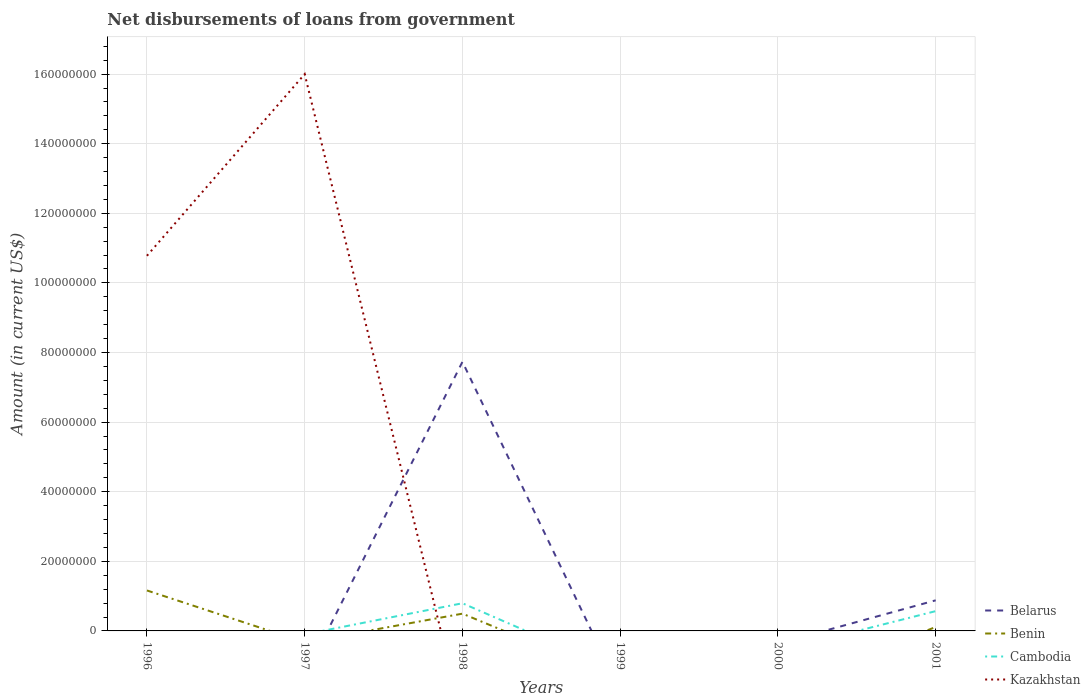Does the line corresponding to Belarus intersect with the line corresponding to Cambodia?
Keep it short and to the point. Yes. Across all years, what is the maximum amount of loan disbursed from government in Kazakhstan?
Your response must be concise. 0. What is the difference between the highest and the second highest amount of loan disbursed from government in Cambodia?
Keep it short and to the point. 7.95e+06. What is the difference between the highest and the lowest amount of loan disbursed from government in Benin?
Provide a short and direct response. 2. Is the amount of loan disbursed from government in Belarus strictly greater than the amount of loan disbursed from government in Kazakhstan over the years?
Your answer should be compact. No. Does the graph contain any zero values?
Provide a succinct answer. Yes. Does the graph contain grids?
Offer a very short reply. Yes. Where does the legend appear in the graph?
Offer a very short reply. Bottom right. How many legend labels are there?
Make the answer very short. 4. What is the title of the graph?
Your answer should be very brief. Net disbursements of loans from government. What is the Amount (in current US$) in Benin in 1996?
Your response must be concise. 1.16e+07. What is the Amount (in current US$) in Kazakhstan in 1996?
Ensure brevity in your answer.  1.08e+08. What is the Amount (in current US$) in Benin in 1997?
Ensure brevity in your answer.  0. What is the Amount (in current US$) of Cambodia in 1997?
Your answer should be compact. 0. What is the Amount (in current US$) in Kazakhstan in 1997?
Your answer should be very brief. 1.60e+08. What is the Amount (in current US$) in Belarus in 1998?
Make the answer very short. 7.73e+07. What is the Amount (in current US$) in Benin in 1998?
Offer a very short reply. 4.96e+06. What is the Amount (in current US$) of Cambodia in 1998?
Your answer should be very brief. 7.95e+06. What is the Amount (in current US$) in Benin in 1999?
Ensure brevity in your answer.  0. What is the Amount (in current US$) in Kazakhstan in 1999?
Your answer should be very brief. 0. What is the Amount (in current US$) of Benin in 2000?
Give a very brief answer. 0. What is the Amount (in current US$) in Cambodia in 2000?
Provide a short and direct response. 0. What is the Amount (in current US$) of Kazakhstan in 2000?
Ensure brevity in your answer.  0. What is the Amount (in current US$) of Belarus in 2001?
Offer a very short reply. 8.79e+06. What is the Amount (in current US$) in Benin in 2001?
Your answer should be very brief. 1.12e+06. What is the Amount (in current US$) of Cambodia in 2001?
Offer a terse response. 5.69e+06. Across all years, what is the maximum Amount (in current US$) of Belarus?
Give a very brief answer. 7.73e+07. Across all years, what is the maximum Amount (in current US$) in Benin?
Give a very brief answer. 1.16e+07. Across all years, what is the maximum Amount (in current US$) in Cambodia?
Give a very brief answer. 7.95e+06. Across all years, what is the maximum Amount (in current US$) of Kazakhstan?
Provide a succinct answer. 1.60e+08. Across all years, what is the minimum Amount (in current US$) of Belarus?
Provide a succinct answer. 0. Across all years, what is the minimum Amount (in current US$) of Benin?
Your answer should be very brief. 0. Across all years, what is the minimum Amount (in current US$) in Kazakhstan?
Your response must be concise. 0. What is the total Amount (in current US$) in Belarus in the graph?
Provide a succinct answer. 8.61e+07. What is the total Amount (in current US$) of Benin in the graph?
Offer a terse response. 1.77e+07. What is the total Amount (in current US$) of Cambodia in the graph?
Give a very brief answer. 1.36e+07. What is the total Amount (in current US$) of Kazakhstan in the graph?
Keep it short and to the point. 2.68e+08. What is the difference between the Amount (in current US$) of Kazakhstan in 1996 and that in 1997?
Keep it short and to the point. -5.22e+07. What is the difference between the Amount (in current US$) in Benin in 1996 and that in 1998?
Offer a very short reply. 6.67e+06. What is the difference between the Amount (in current US$) of Benin in 1996 and that in 2001?
Offer a terse response. 1.05e+07. What is the difference between the Amount (in current US$) of Belarus in 1998 and that in 2001?
Offer a very short reply. 6.85e+07. What is the difference between the Amount (in current US$) in Benin in 1998 and that in 2001?
Provide a succinct answer. 3.84e+06. What is the difference between the Amount (in current US$) in Cambodia in 1998 and that in 2001?
Your response must be concise. 2.26e+06. What is the difference between the Amount (in current US$) in Benin in 1996 and the Amount (in current US$) in Kazakhstan in 1997?
Keep it short and to the point. -1.48e+08. What is the difference between the Amount (in current US$) of Benin in 1996 and the Amount (in current US$) of Cambodia in 1998?
Ensure brevity in your answer.  3.68e+06. What is the difference between the Amount (in current US$) in Benin in 1996 and the Amount (in current US$) in Cambodia in 2001?
Offer a terse response. 5.94e+06. What is the difference between the Amount (in current US$) of Belarus in 1998 and the Amount (in current US$) of Benin in 2001?
Give a very brief answer. 7.62e+07. What is the difference between the Amount (in current US$) in Belarus in 1998 and the Amount (in current US$) in Cambodia in 2001?
Offer a very short reply. 7.16e+07. What is the difference between the Amount (in current US$) of Benin in 1998 and the Amount (in current US$) of Cambodia in 2001?
Give a very brief answer. -7.27e+05. What is the average Amount (in current US$) of Belarus per year?
Offer a very short reply. 1.44e+07. What is the average Amount (in current US$) in Benin per year?
Your response must be concise. 2.95e+06. What is the average Amount (in current US$) of Cambodia per year?
Offer a very short reply. 2.27e+06. What is the average Amount (in current US$) of Kazakhstan per year?
Your answer should be compact. 4.46e+07. In the year 1996, what is the difference between the Amount (in current US$) in Benin and Amount (in current US$) in Kazakhstan?
Provide a short and direct response. -9.62e+07. In the year 1998, what is the difference between the Amount (in current US$) in Belarus and Amount (in current US$) in Benin?
Make the answer very short. 7.24e+07. In the year 1998, what is the difference between the Amount (in current US$) of Belarus and Amount (in current US$) of Cambodia?
Keep it short and to the point. 6.94e+07. In the year 1998, what is the difference between the Amount (in current US$) in Benin and Amount (in current US$) in Cambodia?
Your answer should be compact. -2.99e+06. In the year 2001, what is the difference between the Amount (in current US$) of Belarus and Amount (in current US$) of Benin?
Ensure brevity in your answer.  7.67e+06. In the year 2001, what is the difference between the Amount (in current US$) in Belarus and Amount (in current US$) in Cambodia?
Ensure brevity in your answer.  3.11e+06. In the year 2001, what is the difference between the Amount (in current US$) in Benin and Amount (in current US$) in Cambodia?
Your answer should be very brief. -4.56e+06. What is the ratio of the Amount (in current US$) in Kazakhstan in 1996 to that in 1997?
Provide a short and direct response. 0.67. What is the ratio of the Amount (in current US$) in Benin in 1996 to that in 1998?
Offer a very short reply. 2.34. What is the ratio of the Amount (in current US$) of Benin in 1996 to that in 2001?
Keep it short and to the point. 10.35. What is the ratio of the Amount (in current US$) in Belarus in 1998 to that in 2001?
Your response must be concise. 8.79. What is the ratio of the Amount (in current US$) in Benin in 1998 to that in 2001?
Your answer should be compact. 4.41. What is the ratio of the Amount (in current US$) of Cambodia in 1998 to that in 2001?
Your response must be concise. 1.4. What is the difference between the highest and the second highest Amount (in current US$) in Benin?
Keep it short and to the point. 6.67e+06. What is the difference between the highest and the lowest Amount (in current US$) in Belarus?
Your answer should be very brief. 7.73e+07. What is the difference between the highest and the lowest Amount (in current US$) in Benin?
Your response must be concise. 1.16e+07. What is the difference between the highest and the lowest Amount (in current US$) in Cambodia?
Your answer should be very brief. 7.95e+06. What is the difference between the highest and the lowest Amount (in current US$) of Kazakhstan?
Provide a succinct answer. 1.60e+08. 